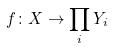<formula> <loc_0><loc_0><loc_500><loc_500>f \colon X \rightarrow \prod _ { i } Y _ { i }</formula> 